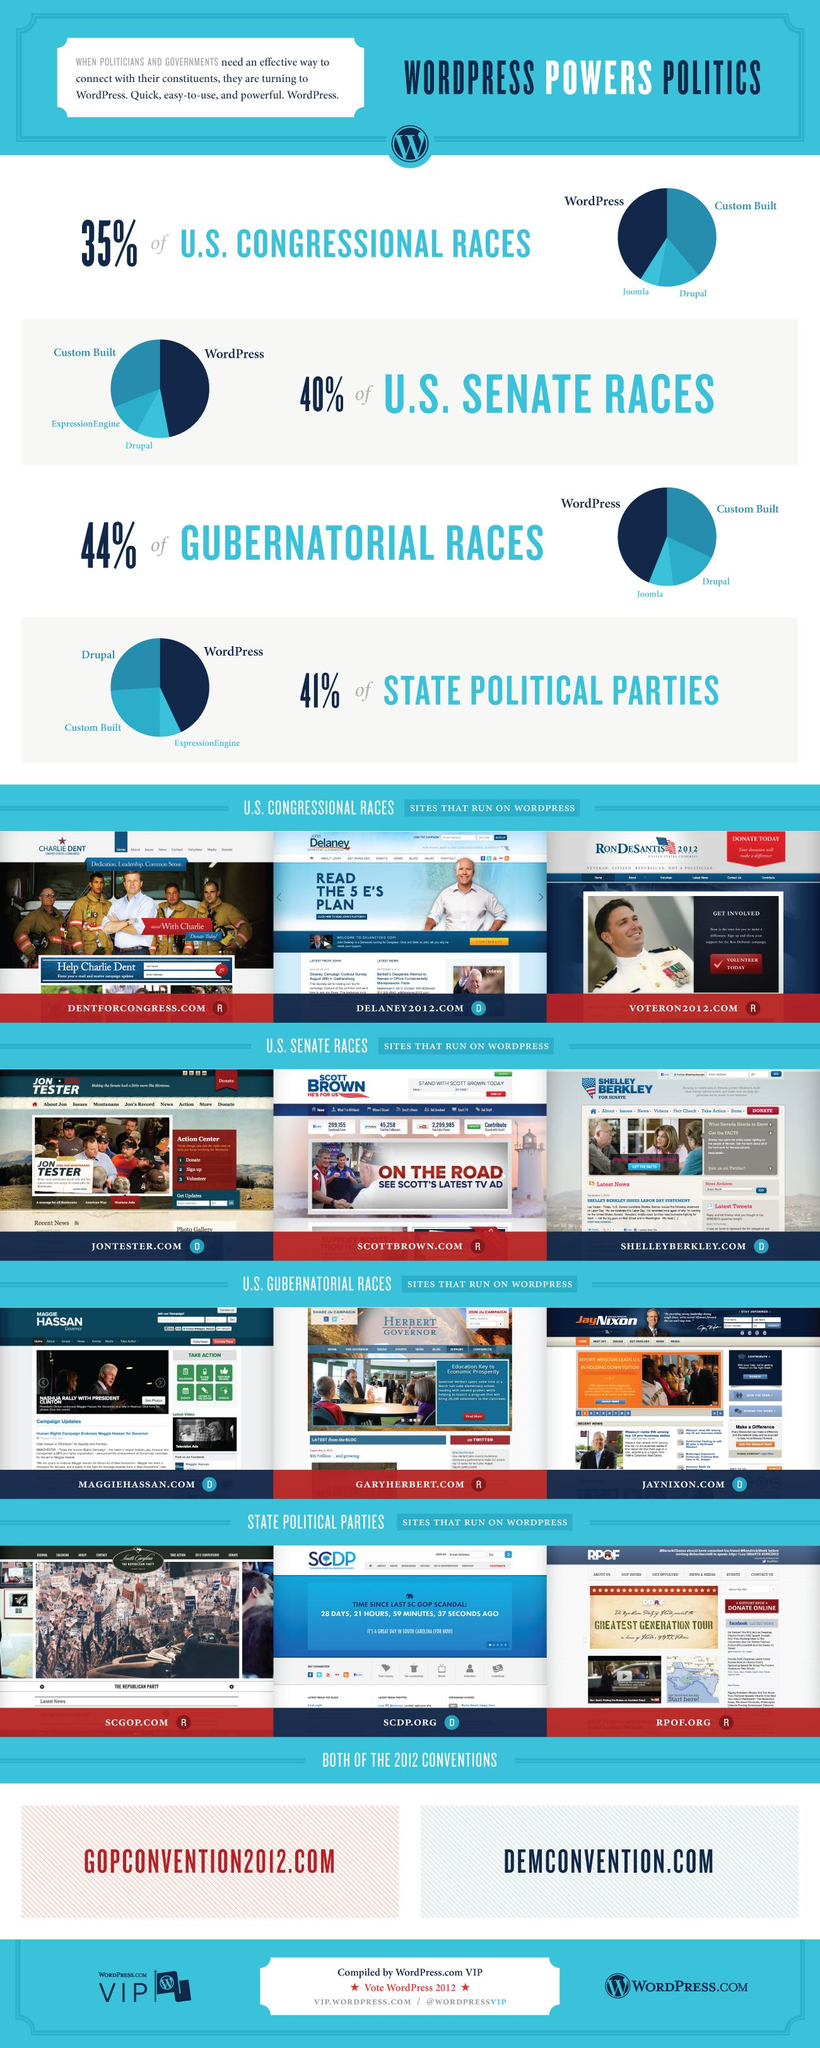Outline some significant characteristics in this image. In addition to using WordPress, U.S. Congressional candidates have several options for connecting with their constituents, including custom-built websites, Joomla, and Drupal. The action center of the website JONTESTER.COM displays three points as options: donating, signing up, and volunteering. The websites of state political parties that run on WordPress are SCGOP.COM, SCDP.ORG, and RPOF.ORG. The websites dentforcongress.com, delaney2012.com, and voteron2012.com operate on the WordPress platform and are focused on the U.S. Congressional races. 